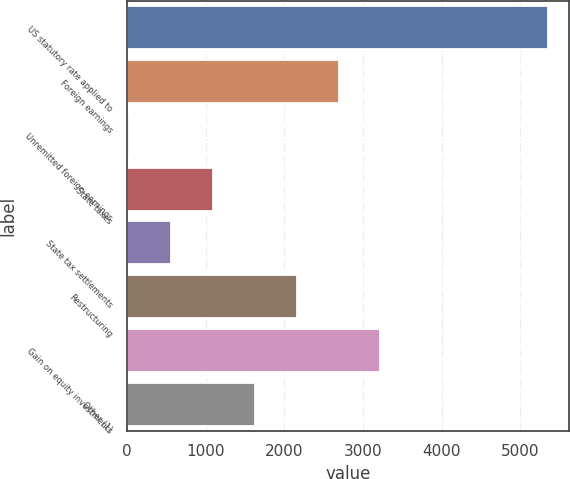<chart> <loc_0><loc_0><loc_500><loc_500><bar_chart><fcel>US statutory rate applied to<fcel>Foreign earnings<fcel>Unremitted foreign earnings<fcel>State taxes<fcel>State tax settlements<fcel>Restructuring<fcel>Gain on equity investments<fcel>Other (1)<nl><fcel>5352<fcel>2689.5<fcel>27<fcel>1092<fcel>559.5<fcel>2157<fcel>3222<fcel>1624.5<nl></chart> 